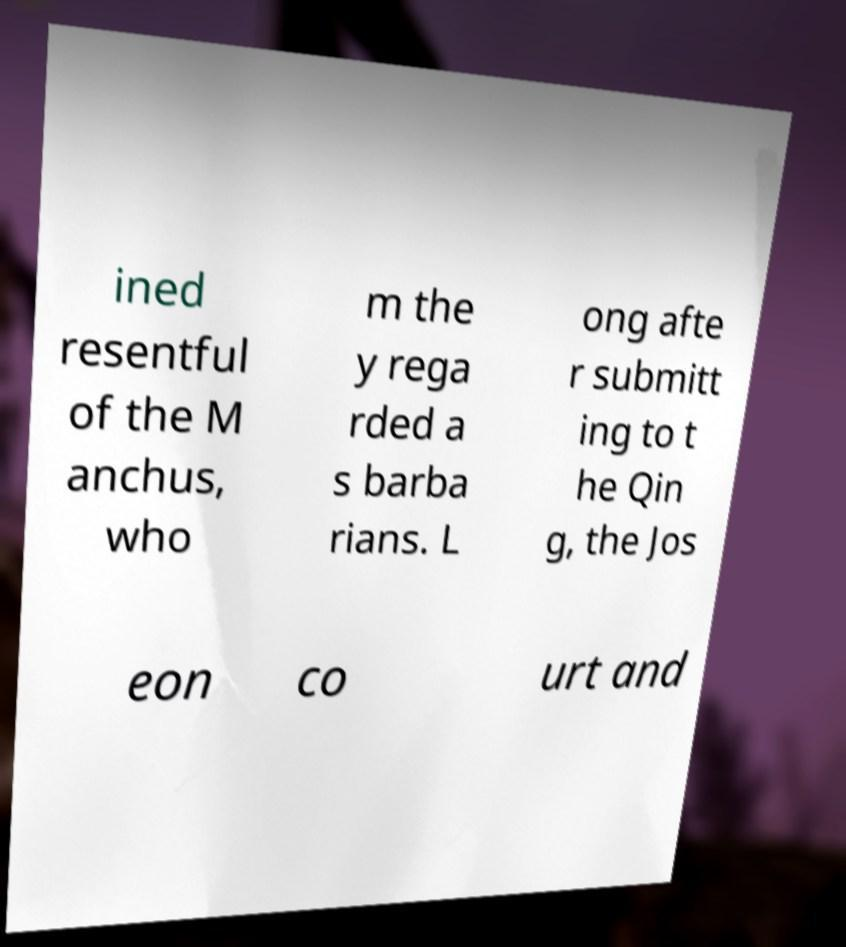For documentation purposes, I need the text within this image transcribed. Could you provide that? ined resentful of the M anchus, who m the y rega rded a s barba rians. L ong afte r submitt ing to t he Qin g, the Jos eon co urt and 